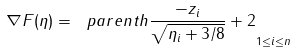<formula> <loc_0><loc_0><loc_500><loc_500>\nabla F ( \eta ) = \ p a r e n t h { \frac { - z _ { i } } { \sqrt { \eta _ { i } + 3 / 8 } } + 2 } _ { 1 \leq i \leq n }</formula> 